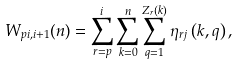Convert formula to latex. <formula><loc_0><loc_0><loc_500><loc_500>W _ { p i , i + 1 } ( n ) = \sum _ { r = p } ^ { i } \sum _ { k = 0 } ^ { n } \sum _ { q = 1 } ^ { Z _ { r } ( k ) } \eta _ { r j } \left ( k , q \right ) ,</formula> 